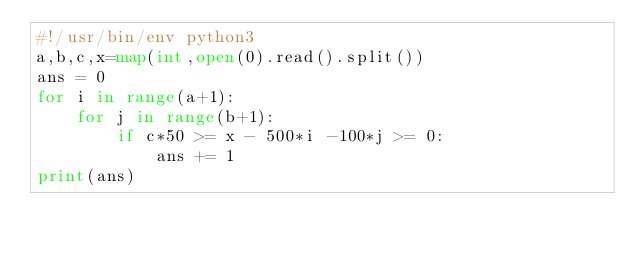<code> <loc_0><loc_0><loc_500><loc_500><_Python_>#!/usr/bin/env python3
a,b,c,x=map(int,open(0).read().split())
ans = 0
for i in range(a+1):
    for j in range(b+1):
        if c*50 >= x - 500*i -100*j >= 0:
            ans += 1
print(ans)
</code> 